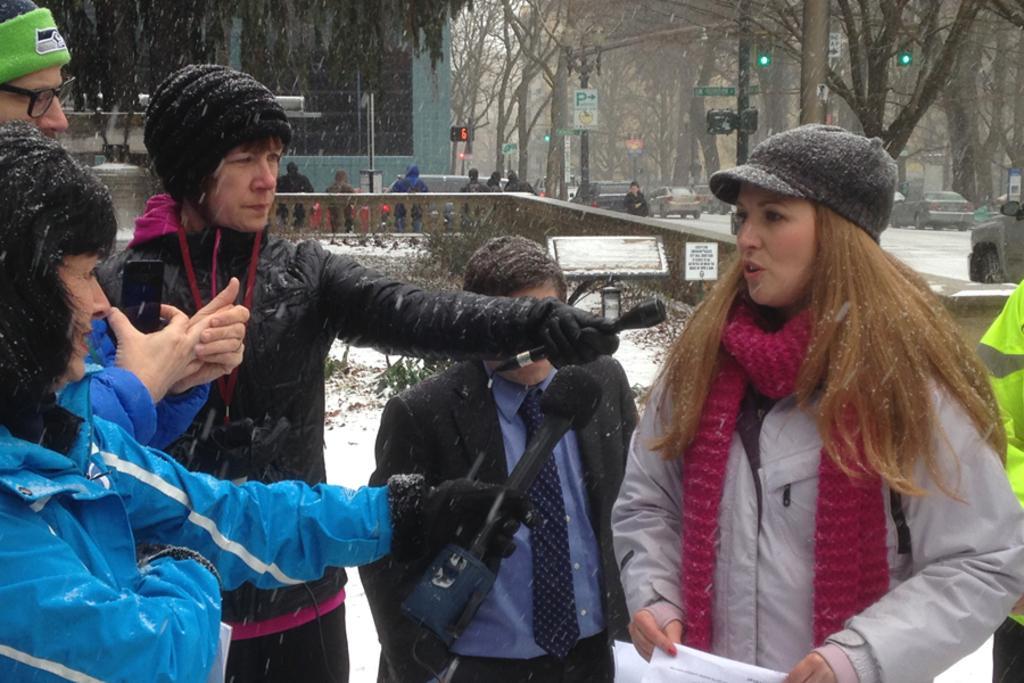Please provide a concise description of this image. In this image we can see a few people, among them, some people are carrying the objects, there are some buildings, trees, poles, lights, vehicles, plants and boards with some text. 